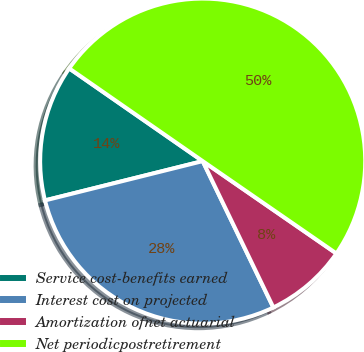Convert chart. <chart><loc_0><loc_0><loc_500><loc_500><pie_chart><fcel>Service cost-benefits earned<fcel>Interest cost on projected<fcel>Amortization ofnet actuarial<fcel>Net periodicpostretirement<nl><fcel>13.55%<fcel>28.27%<fcel>8.22%<fcel>49.96%<nl></chart> 